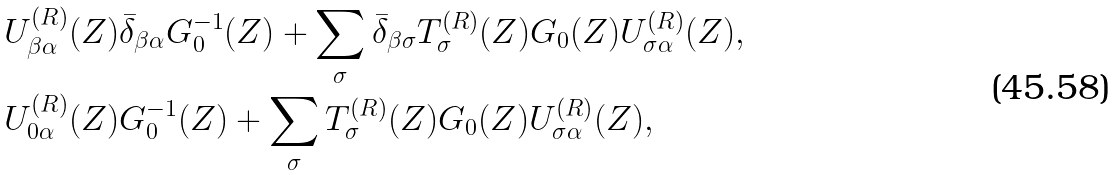Convert formula to latex. <formula><loc_0><loc_0><loc_500><loc_500>U ^ { ( R ) } _ { \beta \alpha } ( Z ) & \bar { \delta } _ { \beta \alpha } G _ { 0 } ^ { - 1 } ( Z ) + \sum _ { \sigma } \bar { \delta } _ { \beta \sigma } T ^ { ( R ) } _ { \sigma } ( Z ) G _ { 0 } ( Z ) U ^ { ( R ) } _ { \sigma \alpha } ( Z ) , \\ U ^ { ( R ) } _ { 0 \alpha } ( Z ) & G _ { 0 } ^ { - 1 } ( Z ) + \sum _ { \sigma } T ^ { ( R ) } _ { \sigma } ( Z ) G _ { 0 } ( Z ) U ^ { ( R ) } _ { \sigma \alpha } ( Z ) ,</formula> 